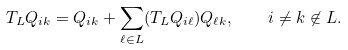Convert formula to latex. <formula><loc_0><loc_0><loc_500><loc_500>T _ { L } Q _ { i k } = Q _ { i k } + \sum _ { \ell \in L } ( T _ { L } Q _ { i \ell } ) Q _ { \ell k } , \quad i \ne k \not \in L .</formula> 